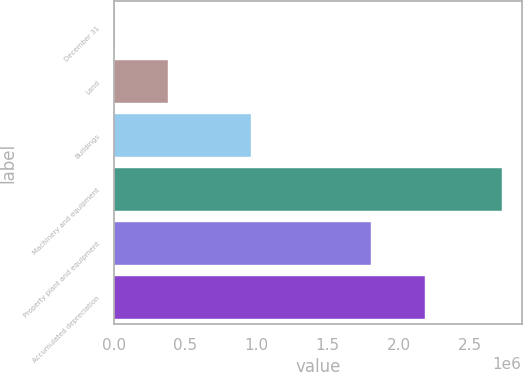Convert chart. <chart><loc_0><loc_0><loc_500><loc_500><bar_chart><fcel>December 31<fcel>Land<fcel>Buildings<fcel>Machinery and equipment<fcel>Property plant and equipment<fcel>Accumulated depreciation<nl><fcel>2013<fcel>379751<fcel>956890<fcel>2.72617e+06<fcel>1.80534e+06<fcel>2.18308e+06<nl></chart> 